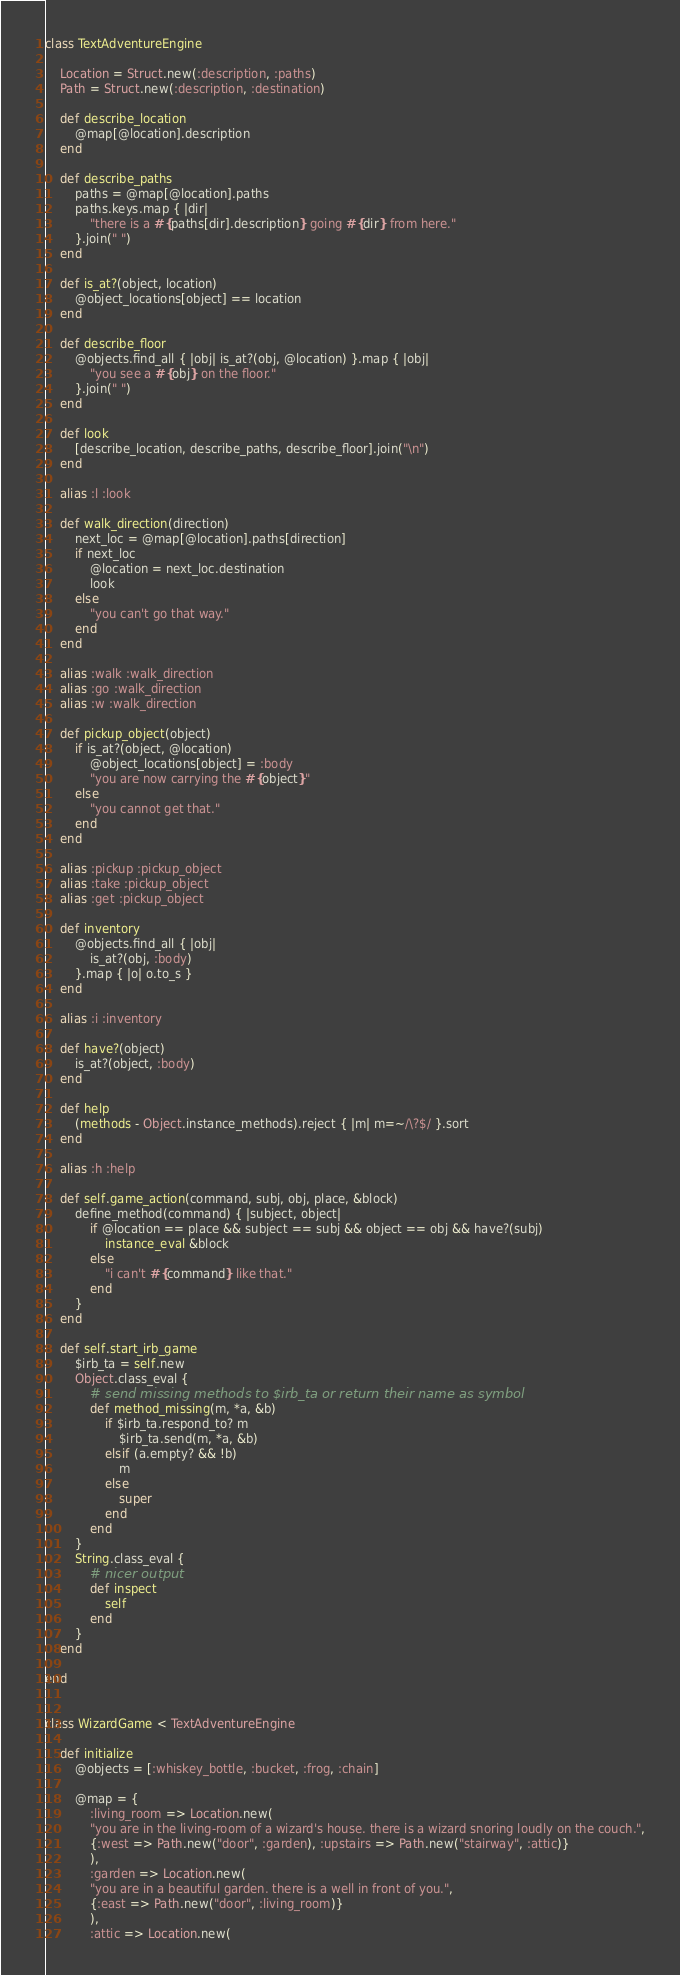Convert code to text. <code><loc_0><loc_0><loc_500><loc_500><_Ruby_>
class TextAdventureEngine

	Location = Struct.new(:description, :paths)
	Path = Struct.new(:description, :destination)

	def describe_location
		@map[@location].description
	end

	def describe_paths
		paths = @map[@location].paths
		paths.keys.map { |dir|
			"there is a #{paths[dir].description} going #{dir} from here."
		}.join(" ")
	end

	def is_at?(object, location)
		@object_locations[object] == location
	end

	def describe_floor
		@objects.find_all { |obj| is_at?(obj, @location) }.map { |obj|
			"you see a #{obj} on the floor."
		}.join(" ")
	end

	def look
		[describe_location, describe_paths, describe_floor].join("\n")
	end

	alias :l :look

	def walk_direction(direction)
		next_loc = @map[@location].paths[direction]
		if next_loc
			@location = next_loc.destination
			look
		else
			"you can't go that way."
		end
	end

	alias :walk :walk_direction
	alias :go :walk_direction
	alias :w :walk_direction

	def pickup_object(object)
		if is_at?(object, @location)
			@object_locations[object] = :body
			"you are now carrying the #{object}"
		else
			"you cannot get that."
		end
	end

	alias :pickup :pickup_object
	alias :take :pickup_object
	alias :get :pickup_object

	def inventory
		@objects.find_all { |obj|
			is_at?(obj, :body)
		}.map { |o| o.to_s }
	end

	alias :i :inventory

	def have?(object)
		is_at?(object, :body)
	end

	def help
		(methods - Object.instance_methods).reject { |m| m=~/\?$/ }.sort
	end

	alias :h :help

	def self.game_action(command, subj, obj, place, &block)
		define_method(command) { |subject, object|
			if @location == place && subject == subj && object == obj && have?(subj)
				instance_eval &block
			else
				"i can't #{command} like that."
			end
		}
	end

	def self.start_irb_game
		$irb_ta = self.new
		Object.class_eval {
			# send missing methods to $irb_ta or return their name as symbol
			def method_missing(m, *a, &b)
				if $irb_ta.respond_to? m
					$irb_ta.send(m, *a, &b)
				elsif (a.empty? && !b)
					m
				else
					super
				end
			end
		}
		String.class_eval {
			# nicer output
			def inspect
				self
			end
		}
	end

end


class WizardGame < TextAdventureEngine

	def initialize
		@objects = [:whiskey_bottle, :bucket, :frog, :chain]

		@map = {
			:living_room => Location.new(
			"you are in the living-room of a wizard's house. there is a wizard snoring loudly on the couch.",
			{:west => Path.new("door", :garden), :upstairs => Path.new("stairway", :attic)}
			),
			:garden => Location.new(
			"you are in a beautiful garden. there is a well in front of you.",
			{:east => Path.new("door", :living_room)}
			),
			:attic => Location.new(</code> 